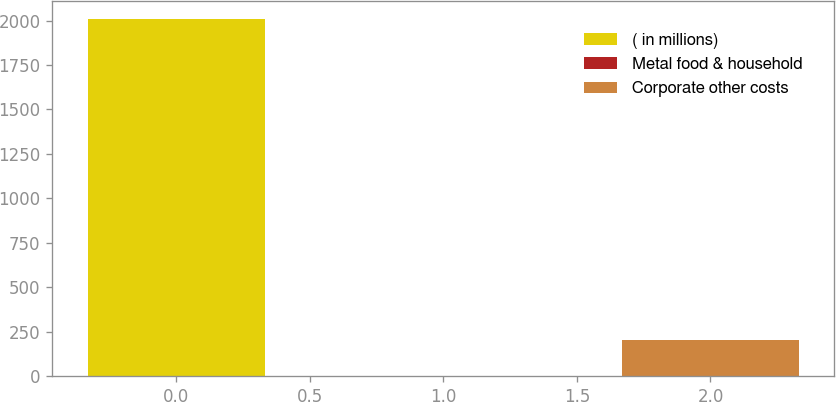<chart> <loc_0><loc_0><loc_500><loc_500><bar_chart><fcel>( in millions)<fcel>Metal food & household<fcel>Corporate other costs<nl><fcel>2009<fcel>2.6<fcel>203.24<nl></chart> 